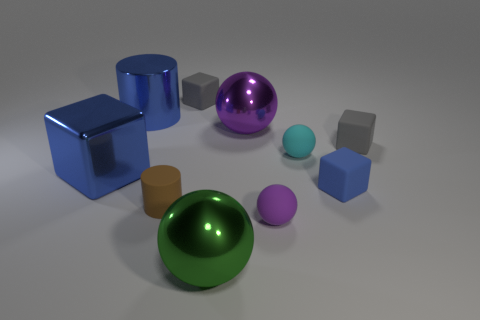Subtract all spheres. How many objects are left? 6 Subtract all big green balls. Subtract all matte blocks. How many objects are left? 6 Add 6 blue matte things. How many blue matte things are left? 7 Add 8 rubber spheres. How many rubber spheres exist? 10 Subtract 1 purple spheres. How many objects are left? 9 